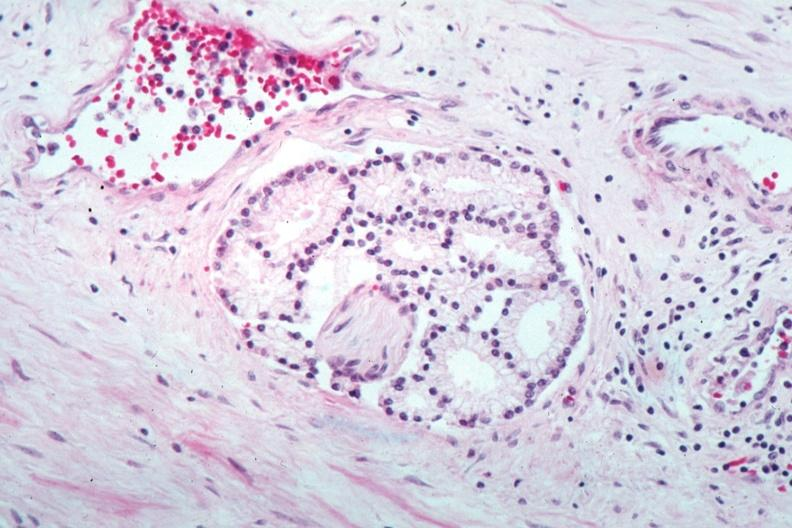s adenocarcinoma present?
Answer the question using a single word or phrase. Yes 